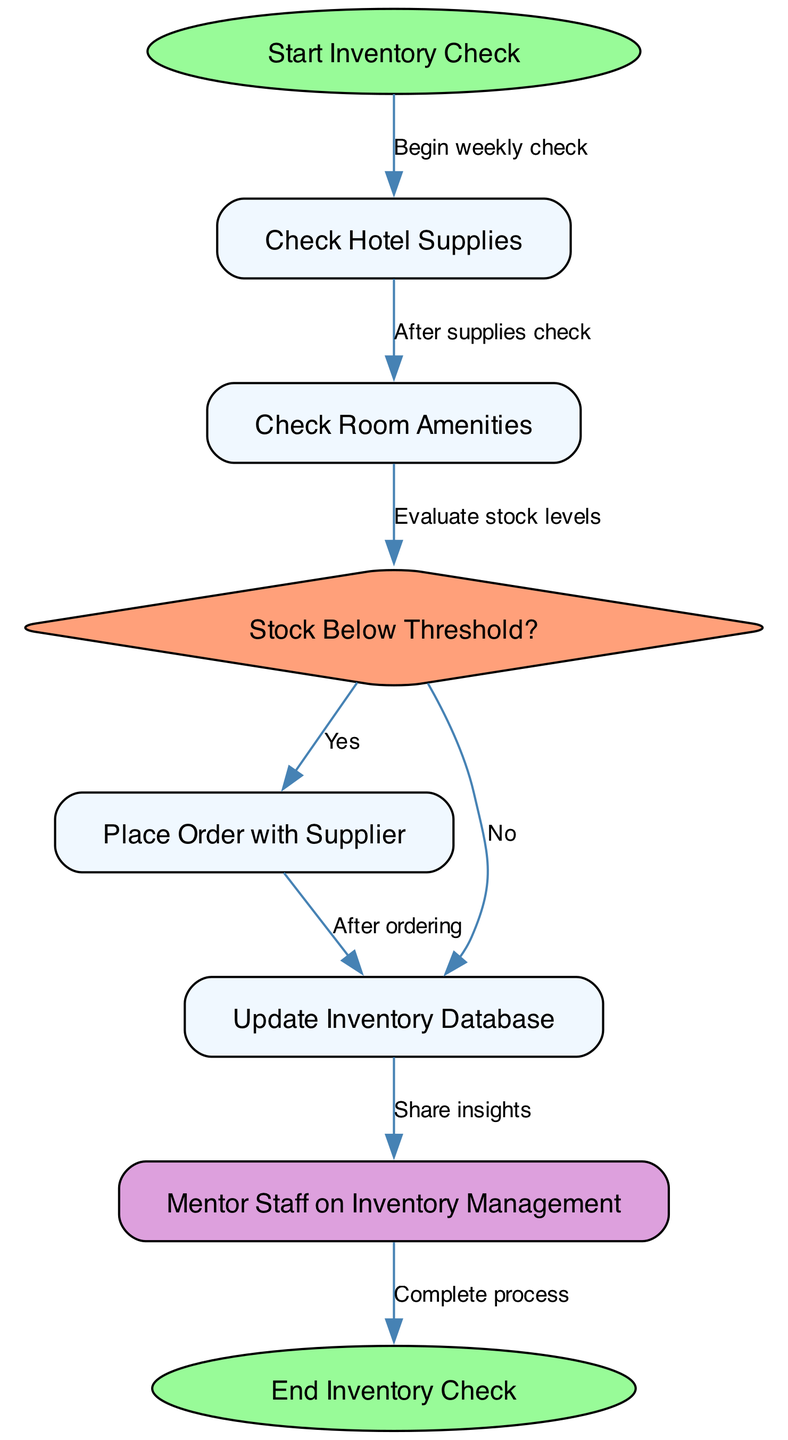What is the starting node of the diagram? The starting node is labeled as "Start Inventory Check", which begins the flow of the inventory management process.
Answer: Start Inventory Check How many nodes are present in the diagram? There are a total of 8 nodes depicted in the diagram representing various stages of the inventory management process.
Answer: 8 What is the ending node of the flowchart? The ending node labeled "End Inventory Check" concludes the flow after the inventory process is completed correctly.
Answer: End Inventory Check Which node leads to placing an order? The node "Stock Below Threshold?" directly leads to "Place Order with Supplier" if the stock level is assessed as low.
Answer: Place Order with Supplier What type of node is "Stock Below Threshold?" This node is a diamond shape, indicating a decision point where stock levels are evaluated for inventory management.
Answer: diamond What action follows the update of inventory? After updating the inventory database, the next action is to "Mentor Staff on Inventory Management", which involves sharing insights learned from the inventory process.
Answer: Mentor Staff on Inventory Management If the stock is above the threshold, what node follows after "Stock Below Threshold?" If stock is not below the threshold, the flow would continue to the "Update Inventory Database" directly from the decision node.
Answer: Update Inventory Database What is the relationship between "Check Room Amenities" and "Stock Below Threshold?" "Check Room Amenities" evaluates stock levels and leads directly to "Stock Below Threshold?", where the decision concerning stock levels is made.
Answer: Evaluate stock levels How many edges are in the diagram? There are 7 edges in the diagram that illustrate the flow of processes between the various nodes.
Answer: 7 